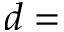Convert formula to latex. <formula><loc_0><loc_0><loc_500><loc_500>d =</formula> 